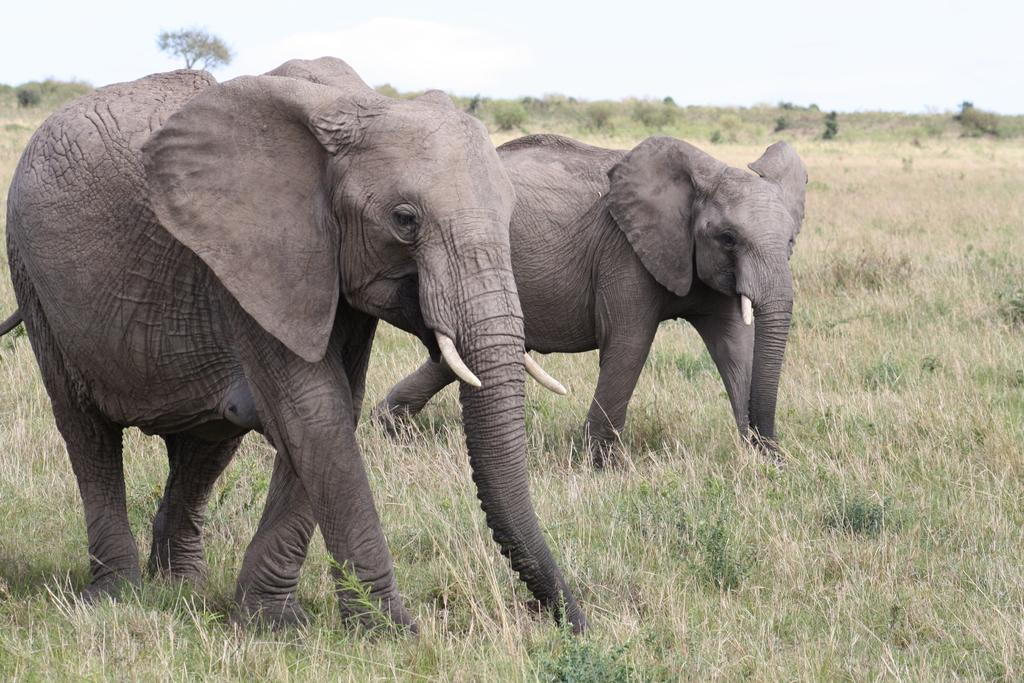How many elephants are in the image? There are two elephants in the image. In which direction are the elephants facing? The elephants are facing towards the right side. What type of vegetation can be seen at the bottom of the image? There is grass visible at the bottom of the image. What can be seen in the background of the image? There are trees in the background of the image. What is visible at the top of the image? The sky is visible at the top of the image. What type of food is the elephant holding in its leg in the image? There is no food or leg visible in the image; the elephants are not holding anything. What type of amusement park can be seen in the background of the image? There is no amusement park present in the image; it features two elephants, grass, trees, and the sky. 